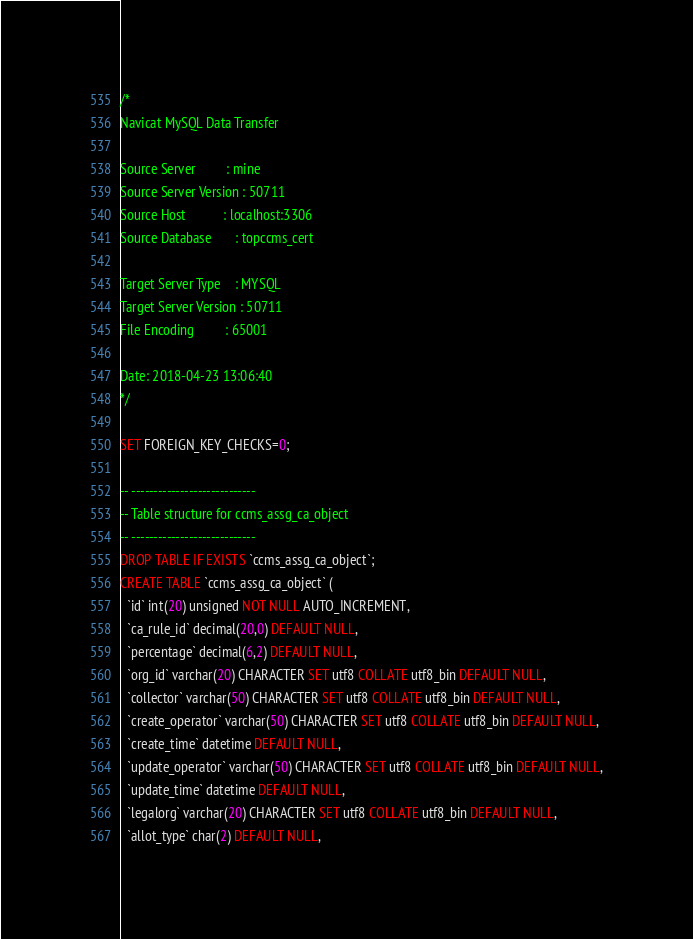<code> <loc_0><loc_0><loc_500><loc_500><_SQL_>/*
Navicat MySQL Data Transfer

Source Server         : mine
Source Server Version : 50711
Source Host           : localhost:3306
Source Database       : topccms_cert

Target Server Type    : MYSQL
Target Server Version : 50711
File Encoding         : 65001

Date: 2018-04-23 13:06:40
*/

SET FOREIGN_KEY_CHECKS=0;

-- ----------------------------
-- Table structure for ccms_assg_ca_object
-- ----------------------------
DROP TABLE IF EXISTS `ccms_assg_ca_object`;
CREATE TABLE `ccms_assg_ca_object` (
  `id` int(20) unsigned NOT NULL AUTO_INCREMENT,
  `ca_rule_id` decimal(20,0) DEFAULT NULL,
  `percentage` decimal(6,2) DEFAULT NULL,
  `org_id` varchar(20) CHARACTER SET utf8 COLLATE utf8_bin DEFAULT NULL,
  `collector` varchar(50) CHARACTER SET utf8 COLLATE utf8_bin DEFAULT NULL,
  `create_operator` varchar(50) CHARACTER SET utf8 COLLATE utf8_bin DEFAULT NULL,
  `create_time` datetime DEFAULT NULL,
  `update_operator` varchar(50) CHARACTER SET utf8 COLLATE utf8_bin DEFAULT NULL,
  `update_time` datetime DEFAULT NULL,
  `legalorg` varchar(20) CHARACTER SET utf8 COLLATE utf8_bin DEFAULT NULL,
  `allot_type` char(2) DEFAULT NULL,</code> 